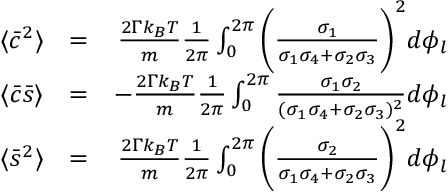<formula> <loc_0><loc_0><loc_500><loc_500>\begin{array} { r l r } { \langle \bar { c } ^ { 2 } \rangle } & { = } & { \frac { 2 \Gamma k _ { B } T } { m } \frac { 1 } { 2 \pi } \int _ { 0 } ^ { 2 \pi } \left ( \frac { \sigma _ { 1 } } { \sigma _ { 1 } \sigma _ { 4 } + \sigma _ { 2 } \sigma _ { 3 } } \right ) ^ { 2 } d \phi _ { l } } \\ { \langle \bar { c } \bar { s } \rangle } & { = } & { - \frac { 2 \Gamma k _ { B } T } { m } \frac { 1 } { 2 \pi } \int _ { 0 } ^ { 2 \pi } \frac { \sigma _ { 1 } \sigma _ { 2 } } { ( \sigma _ { 1 } \sigma _ { 4 } + \sigma _ { 2 } \sigma _ { 3 } ) ^ { 2 } } d \phi _ { l } } \\ { \langle \bar { s } ^ { 2 } \rangle } & { = } & { \frac { 2 \Gamma k _ { B } T } { m } \frac { 1 } { 2 \pi } \int _ { 0 } ^ { 2 \pi } \left ( \frac { \sigma _ { 2 } } { \sigma _ { 1 } \sigma _ { 4 } + \sigma _ { 2 } \sigma _ { 3 } } \right ) ^ { 2 } d \phi _ { l } } \end{array}</formula> 